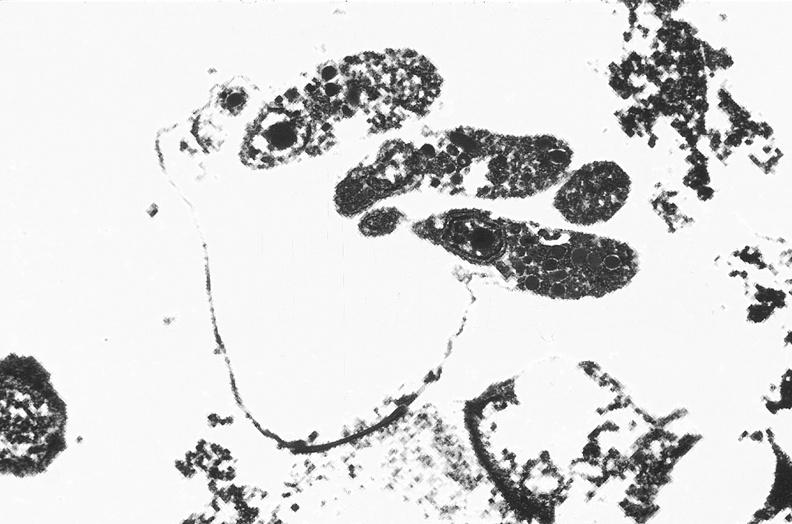does this image show colon, cryptosporidia?
Answer the question using a single word or phrase. Yes 